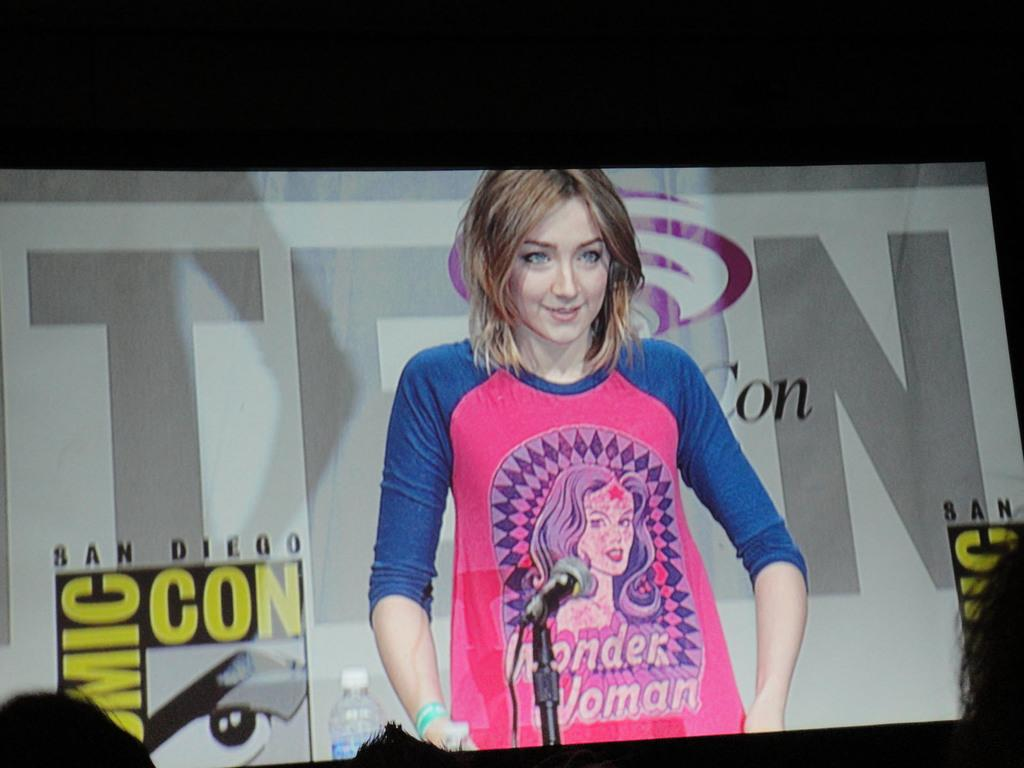What is the main object in the image? There is a projector screen in the image. What is the girl doing in the image? The girl is standing at a speech desk in the image. What can be observed about the girl's clothing? The girl is wearing a blue and pink color t-shirt. How many wrens can be seen flying around the speech desk in the image? There are no wrens present in the image. What is the distance between the projector screen and the speech desk in the image? The distance between the projector screen and the speech desk cannot be determined from the image. 